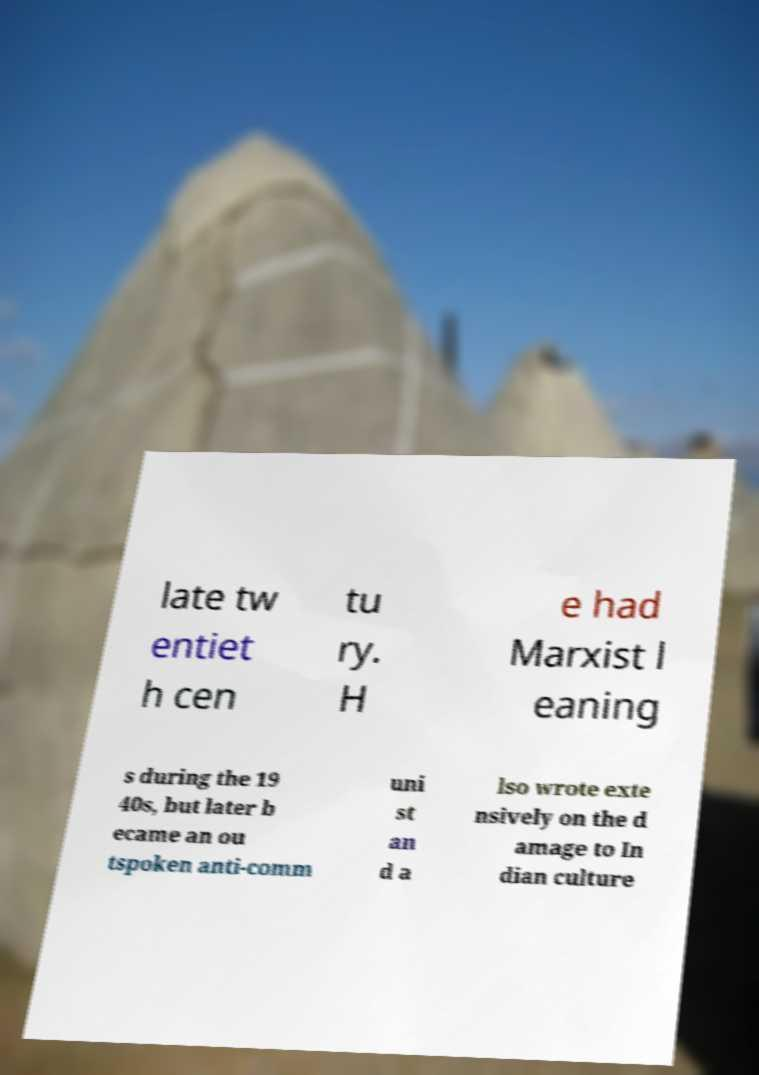I need the written content from this picture converted into text. Can you do that? late tw entiet h cen tu ry. H e had Marxist l eaning s during the 19 40s, but later b ecame an ou tspoken anti-comm uni st an d a lso wrote exte nsively on the d amage to In dian culture 